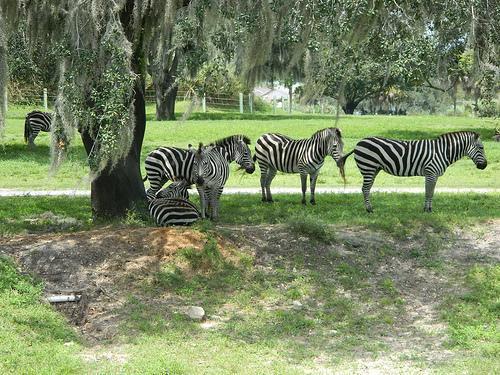How many animals are pictured?
Give a very brief answer. 6. How many people are pictured here?
Give a very brief answer. 0. 